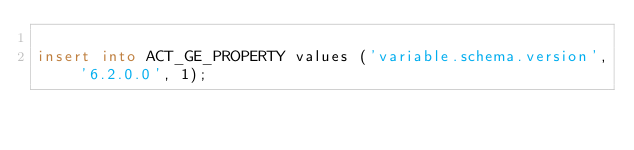<code> <loc_0><loc_0><loc_500><loc_500><_SQL_>
insert into ACT_GE_PROPERTY values ('variable.schema.version', '6.2.0.0', 1);</code> 